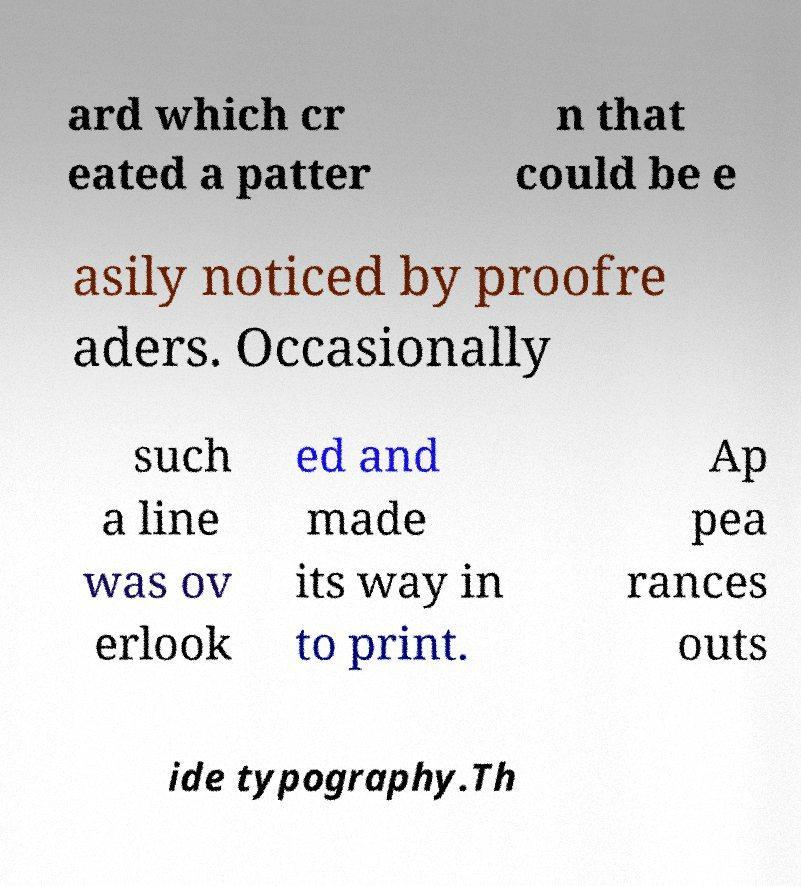Please identify and transcribe the text found in this image. ard which cr eated a patter n that could be e asily noticed by proofre aders. Occasionally such a line was ov erlook ed and made its way in to print. Ap pea rances outs ide typography.Th 